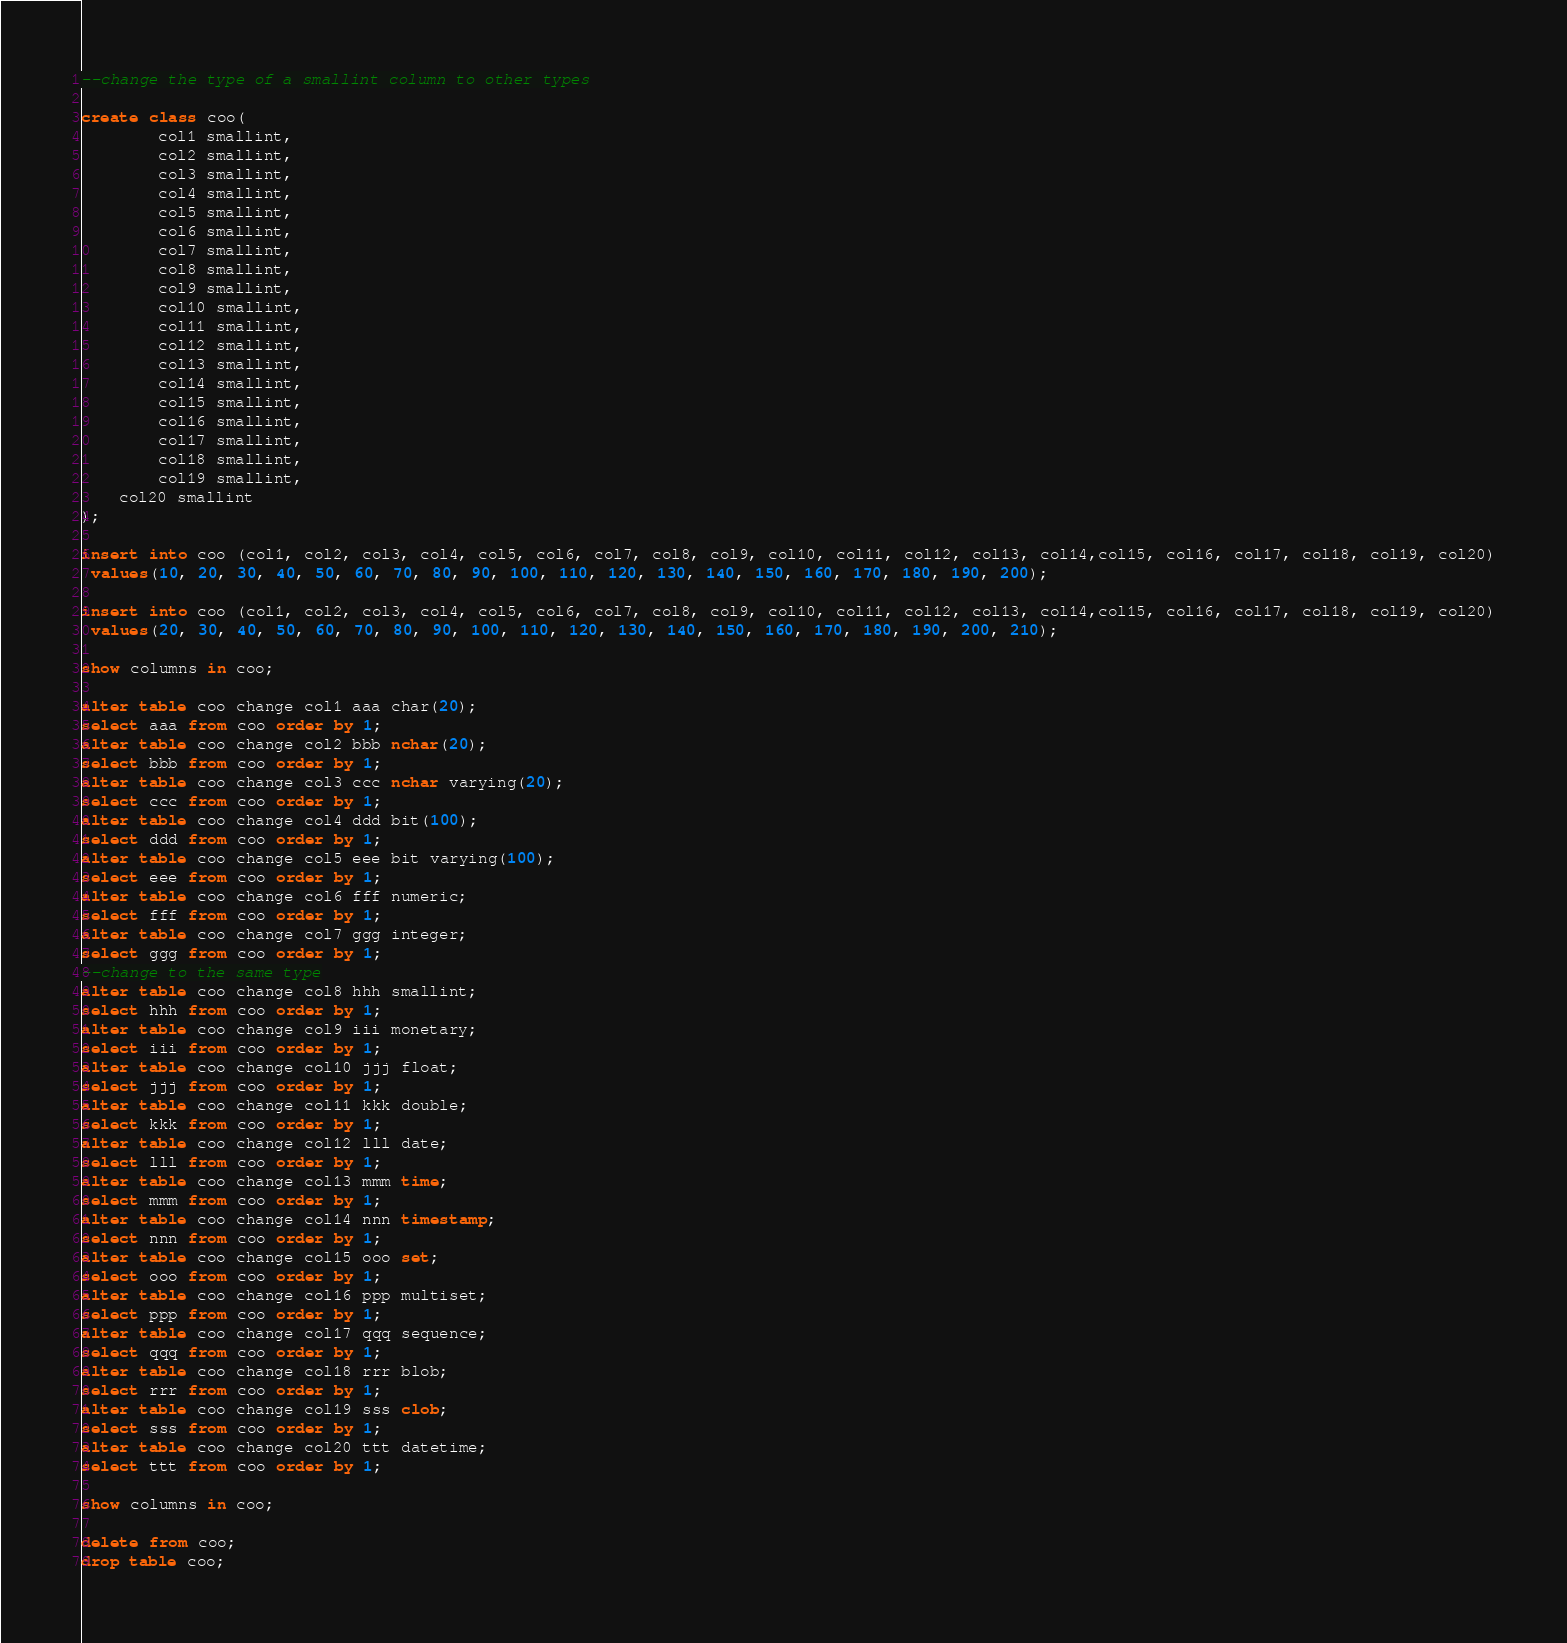<code> <loc_0><loc_0><loc_500><loc_500><_SQL_>--change the type of a smallint column to other types

create class coo(
        col1 smallint,
        col2 smallint,
        col3 smallint,
        col4 smallint,
        col5 smallint,
        col6 smallint,
        col7 smallint,
        col8 smallint,
        col9 smallint,
        col10 smallint,
        col11 smallint,
        col12 smallint,
        col13 smallint,
        col14 smallint,
        col15 smallint,
        col16 smallint,
        col17 smallint,
        col18 smallint,
        col19 smallint,
	col20 smallint
);

insert into coo (col1, col2, col3, col4, col5, col6, col7, col8, col9, col10, col11, col12, col13, col14,col15, col16, col17, col18, col19, col20)
 values(10, 20, 30, 40, 50, 60, 70, 80, 90, 100, 110, 120, 130, 140, 150, 160, 170, 180, 190, 200);

insert into coo (col1, col2, col3, col4, col5, col6, col7, col8, col9, col10, col11, col12, col13, col14,col15, col16, col17, col18, col19, col20)
 values(20, 30, 40, 50, 60, 70, 80, 90, 100, 110, 120, 130, 140, 150, 160, 170, 180, 190, 200, 210);

show columns in coo;

alter table coo change col1 aaa char(20);
select aaa from coo order by 1;
alter table coo change col2 bbb nchar(20);
select bbb from coo order by 1;
alter table coo change col3 ccc nchar varying(20);
select ccc from coo order by 1;
alter table coo change col4 ddd bit(100);
select ddd from coo order by 1;
alter table coo change col5 eee bit varying(100);
select eee from coo order by 1;
alter table coo change col6 fff numeric;
select fff from coo order by 1;
alter table coo change col7 ggg integer;
select ggg from coo order by 1;
--change to the same type
alter table coo change col8 hhh smallint;
select hhh from coo order by 1;
alter table coo change col9 iii monetary;
select iii from coo order by 1;
alter table coo change col10 jjj float;
select jjj from coo order by 1;
alter table coo change col11 kkk double;
select kkk from coo order by 1;
alter table coo change col12 lll date;
select lll from coo order by 1;
alter table coo change col13 mmm time;
select mmm from coo order by 1;
alter table coo change col14 nnn timestamp;
select nnn from coo order by 1;
alter table coo change col15 ooo set;
select ooo from coo order by 1;
alter table coo change col16 ppp multiset;
select ppp from coo order by 1;
alter table coo change col17 qqq sequence;
select qqq from coo order by 1;
alter table coo change col18 rrr blob;
select rrr from coo order by 1;
alter table coo change col19 sss clob;
select sss from coo order by 1;
alter table coo change col20 ttt datetime;
select ttt from coo order by 1;

show columns in coo;

delete from coo;
drop table coo;


</code> 